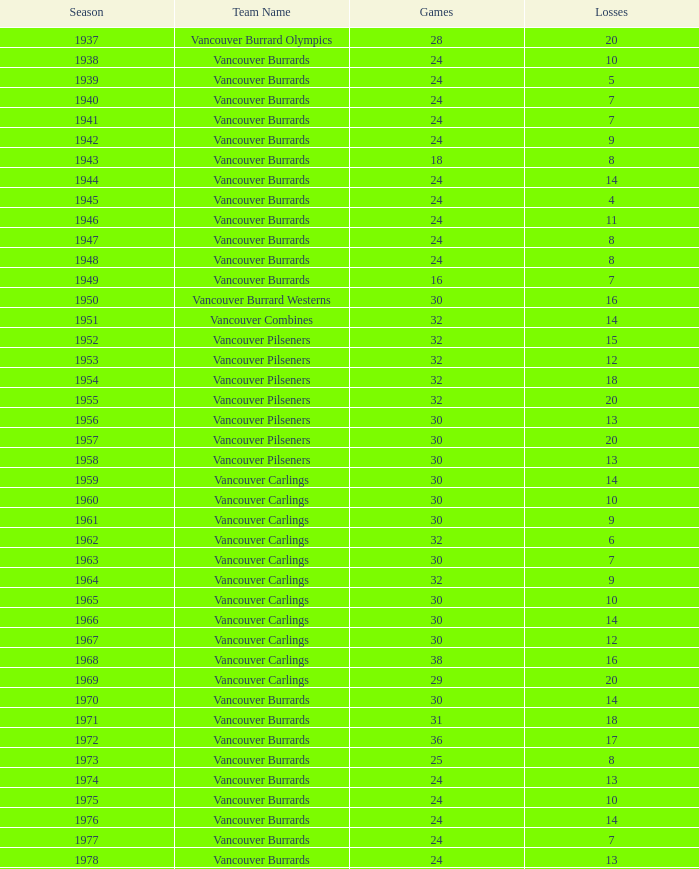When considering the 1963 season with more than 30 games, what is the sum of points? None. 